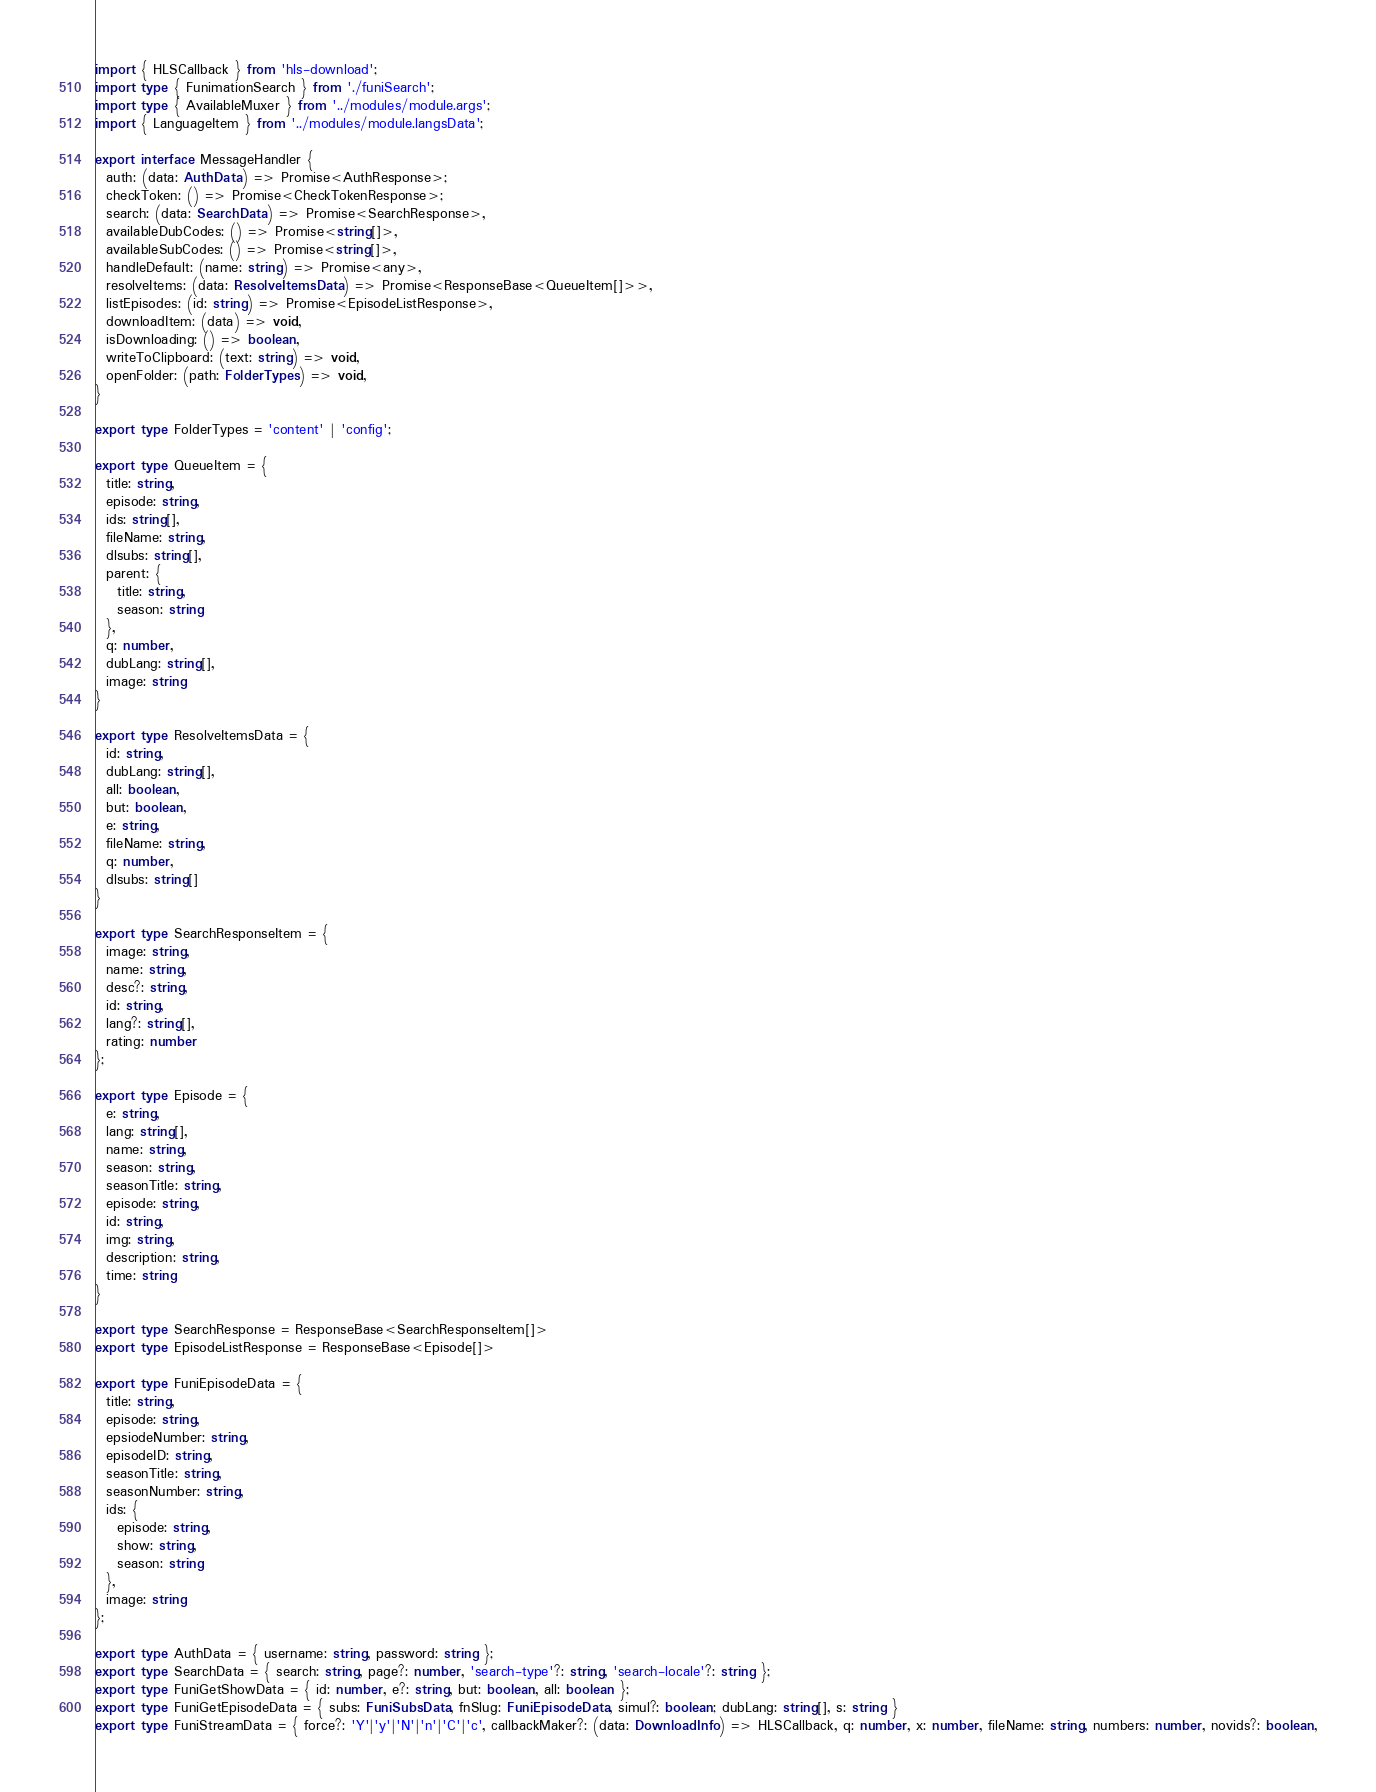<code> <loc_0><loc_0><loc_500><loc_500><_TypeScript_>import { HLSCallback } from 'hls-download';
import type { FunimationSearch } from './funiSearch';
import type { AvailableMuxer } from '../modules/module.args';
import { LanguageItem } from '../modules/module.langsData';

export interface MessageHandler {
  auth: (data: AuthData) => Promise<AuthResponse>;
  checkToken: () => Promise<CheckTokenResponse>;
  search: (data: SearchData) => Promise<SearchResponse>,
  availableDubCodes: () => Promise<string[]>,
  availableSubCodes: () => Promise<string[]>,
  handleDefault: (name: string) => Promise<any>,
  resolveItems: (data: ResolveItemsData) => Promise<ResponseBase<QueueItem[]>>,
  listEpisodes: (id: string) => Promise<EpisodeListResponse>,
  downloadItem: (data) => void,
  isDownloading: () => boolean,
  writeToClipboard: (text: string) => void,
  openFolder: (path: FolderTypes) => void,
}

export type FolderTypes = 'content' | 'config';

export type QueueItem = {
  title: string,
  episode: string,
  ids: string[],
  fileName: string,
  dlsubs: string[],
  parent: {
    title: string,
    season: string
  },
  q: number,
  dubLang: string[],
  image: string
}

export type ResolveItemsData = {
  id: string,
  dubLang: string[],
  all: boolean,
  but: boolean,
  e: string,
  fileName: string,
  q: number,
  dlsubs: string[]
}

export type SearchResponseItem = {
  image: string,
  name: string,
  desc?: string,
  id: string,
  lang?: string[],
  rating: number
};

export type Episode = {
  e: string,
  lang: string[],
  name: string,
  season: string,
  seasonTitle: string,
  episode: string,
  id: string,
  img: string,
  description: string,
  time: string
}

export type SearchResponse = ResponseBase<SearchResponseItem[]>
export type EpisodeListResponse = ResponseBase<Episode[]>

export type FuniEpisodeData = {
  title: string,
  episode: string,
  epsiodeNumber: string,
  episodeID: string,
  seasonTitle: string,
  seasonNumber: string,
  ids: {
    episode: string,
    show: string,
    season: string
  },
  image: string
};

export type AuthData = { username: string, password: string };
export type SearchData = { search: string, page?: number, 'search-type'?: string, 'search-locale'?: string };
export type FuniGetShowData = { id: number, e?: string, but: boolean, all: boolean };
export type FuniGetEpisodeData = { subs: FuniSubsData, fnSlug: FuniEpisodeData, simul?: boolean; dubLang: string[], s: string }
export type FuniStreamData = { force?: 'Y'|'y'|'N'|'n'|'C'|'c', callbackMaker?: (data: DownloadInfo) => HLSCallback, q: number, x: number, fileName: string, numbers: number, novids?: boolean,</code> 